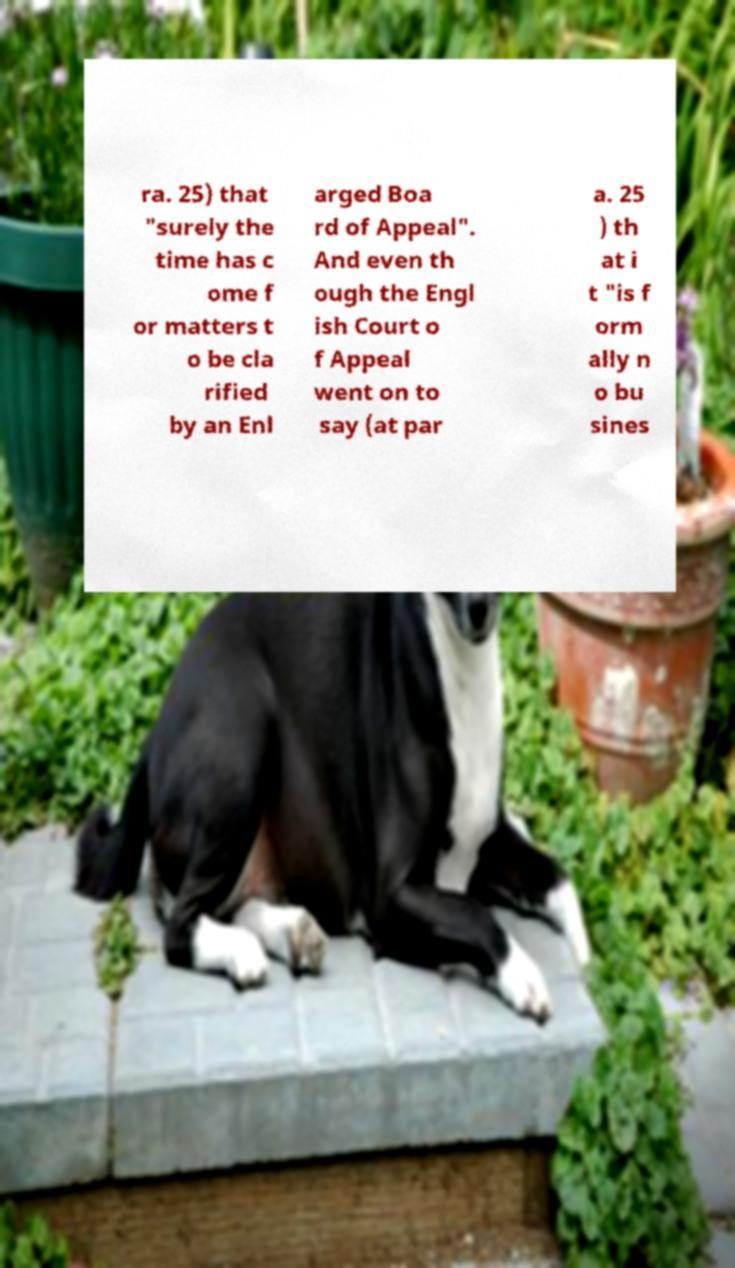Can you read and provide the text displayed in the image?This photo seems to have some interesting text. Can you extract and type it out for me? ra. 25) that "surely the time has c ome f or matters t o be cla rified by an Enl arged Boa rd of Appeal". And even th ough the Engl ish Court o f Appeal went on to say (at par a. 25 ) th at i t "is f orm ally n o bu sines 